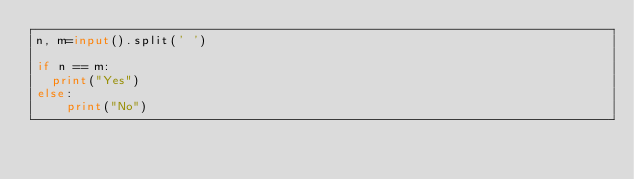Convert code to text. <code><loc_0><loc_0><loc_500><loc_500><_Python_>n, m=input().split(' ')
     
if n == m:
  print("Yes")
else:
    print("No")</code> 